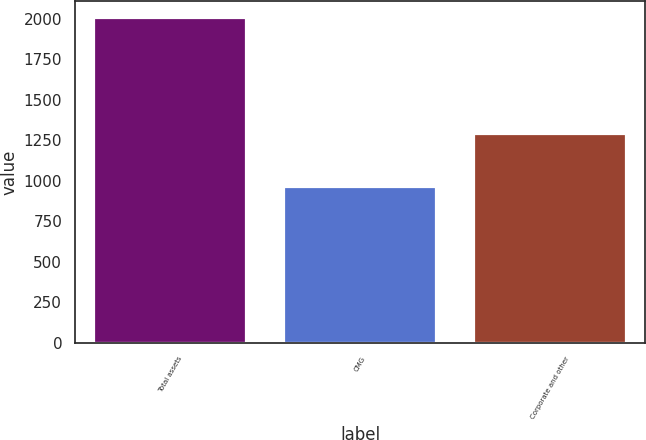<chart> <loc_0><loc_0><loc_500><loc_500><bar_chart><fcel>Total assets<fcel>CMG<fcel>Corporate and other<nl><fcel>2007<fcel>961.2<fcel>1285<nl></chart> 